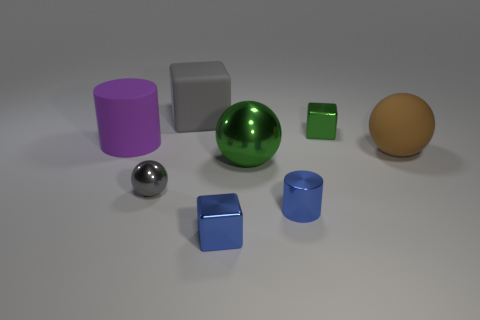Can you describe the shape and color of the objects to the right of the green sphere? To the right of the green sphere, there is a tiny green cube and a large orange sphere. The green cube has a solid, vibrant green color and sharp edges denoting its precise cubic shape. The orange sphere has a soft, muted orange hue, and its perfectly round shape is highlighted by the subtle reflections and soft shadows cast by the lighting. 